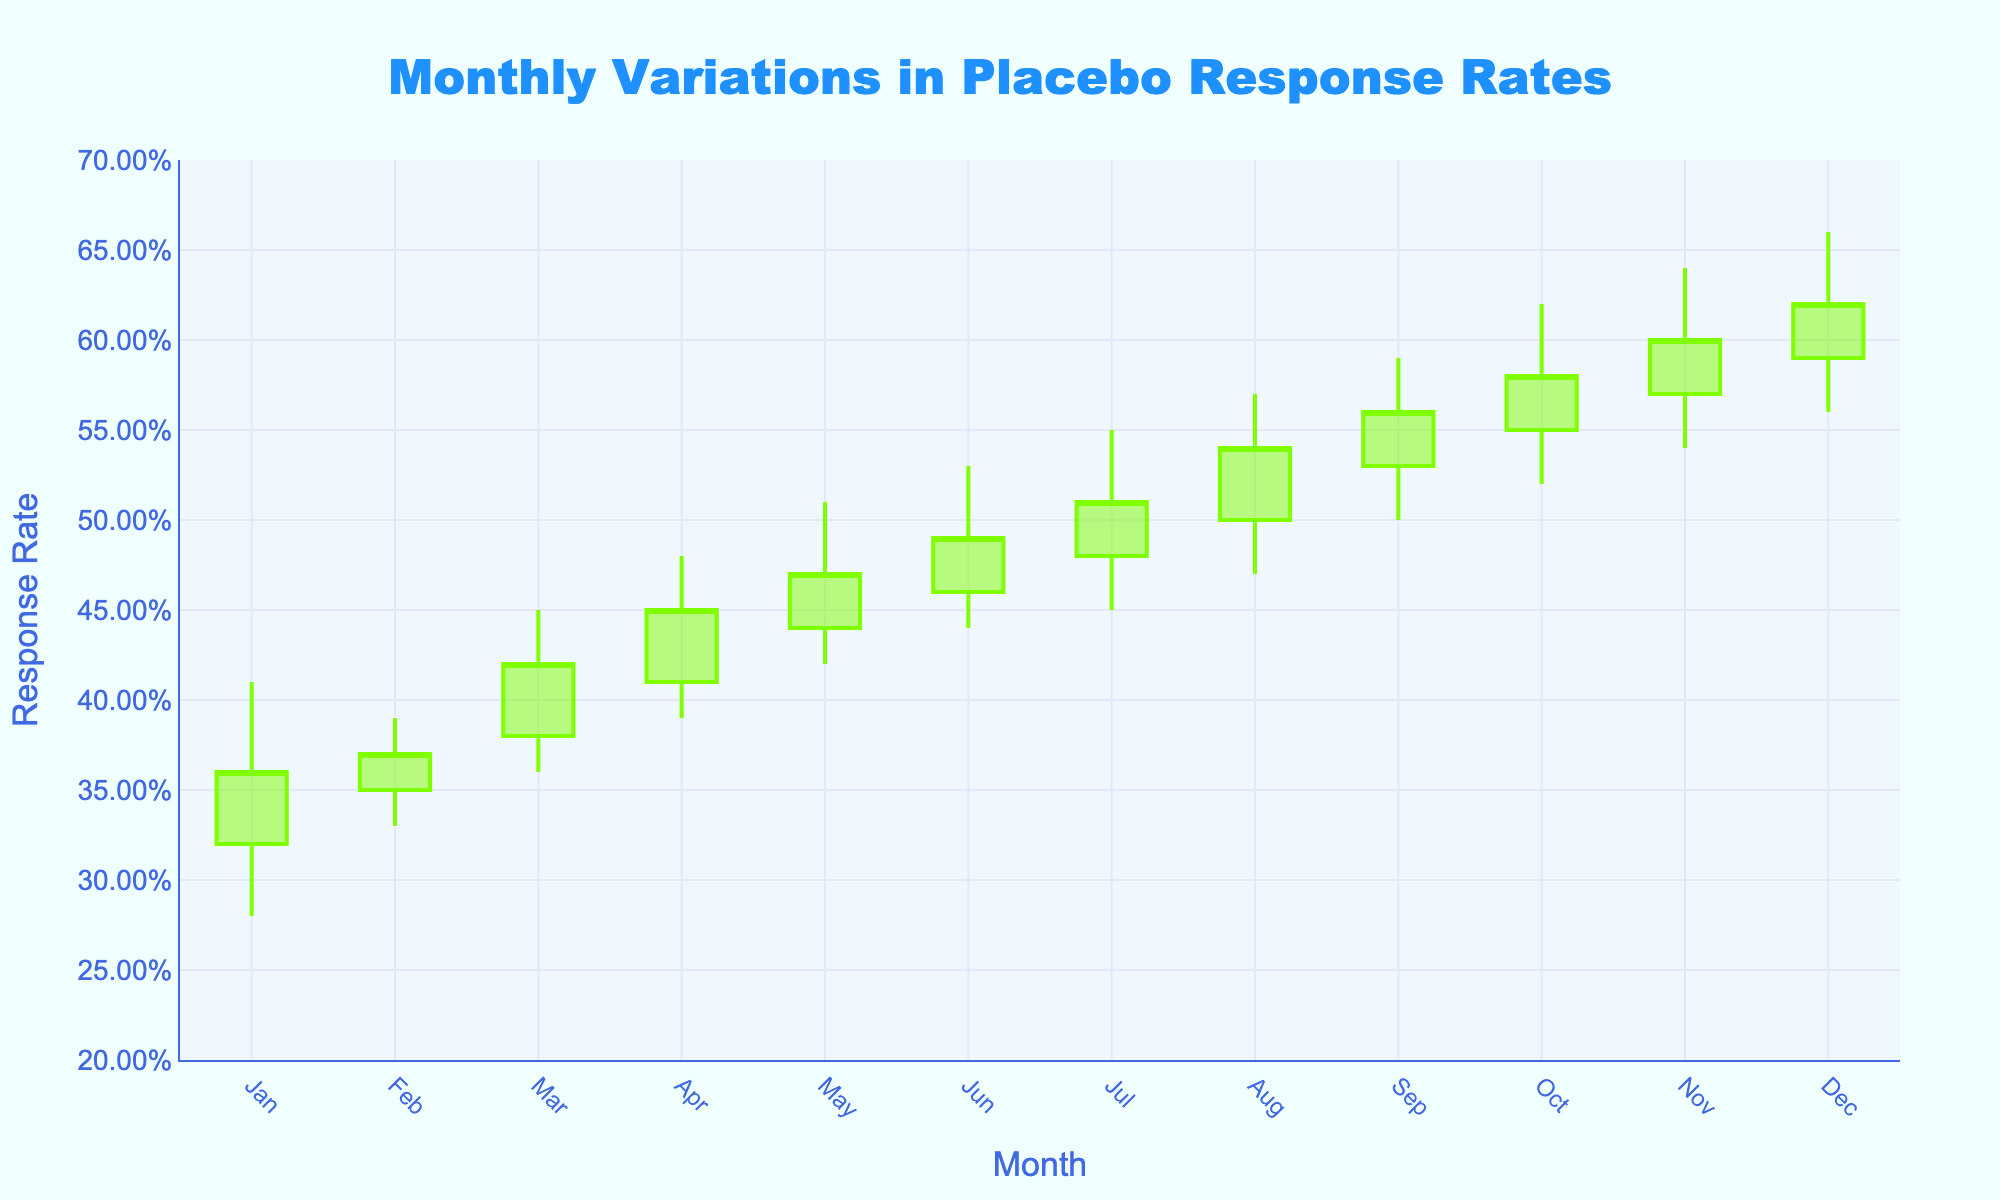What is the title of the chart? The title is located at the top center of the chart. It reads "Monthly Variations in Placebo Response Rates".
Answer: Monthly Variations in Placebo Response Rates What color is used to indicate an increasing response rate on the chart? The increasing response rate is represented by the color of the candlesticks when the 'Close' value is higher than the 'Open' value. This color is bright green.
Answer: Bright green Which month had the highest placebo response rate? The month with the highest placebo response rate can be determined by looking at the highest 'High' value on the chart, which is 0.66 in December.
Answer: December What was the lowest placebo response rate observed, and in which month did it occur? The lowest placebo response rate is indicated by the lowest 'Low' value on the chart. This value is 0.28, and it occurred in January.
Answer: 0.28 in January How did the response rate change from January to February? Compare the 'Close' value of January (0.36) with that of February (0.37). The response rate increased by 0.01.
Answer: Increased by 0.01 Which two consecutive months had the largest increase in the placebo response rate? To determine this, calculate the difference in the 'Close' values between each pair of consecutive months. The largest increase is from March to April, where the rate increased from 0.42 to 0.45, an increase of 0.03.
Answer: March to April, with an increase of 0.03 What is the average 'Close' value over the 12 months? Sum the 'Close' values for each month and divide by 12. The 'Close' values sum to (0.36 + 0.37 + 0.42 + 0.45 + 0.47 + 0.49 + 0.51 + 0.54 + 0.56 + 0.58 + 0.60 + 0.62) = 5.97. The average is 5.97 / 12 ≈ 0.50.
Answer: 0.50 In which month did the placebo response rate remain the same? The response rate remains the same when the 'Close' value equals the 'Open' value. In none of the months does this occur, so the response rate never remains the same.
Answer: None By how much did the 'High' value increase from January to December? To find this, subtract the 'High' value in January (0.41) from the 'High' value in December (0.66). The increase is 0.66 - 0.41 = 0.25.
Answer: 0.25 What is the range of placebo response rates observed in the data? The range is calculated by subtracting the minimum 'Low' value from the maximum 'High' value. The lowest 'Low' is 0.28 (January), and the highest 'High' is 0.66 (December). The range is 0.66 - 0.28 = 0.38.
Answer: 0.38 